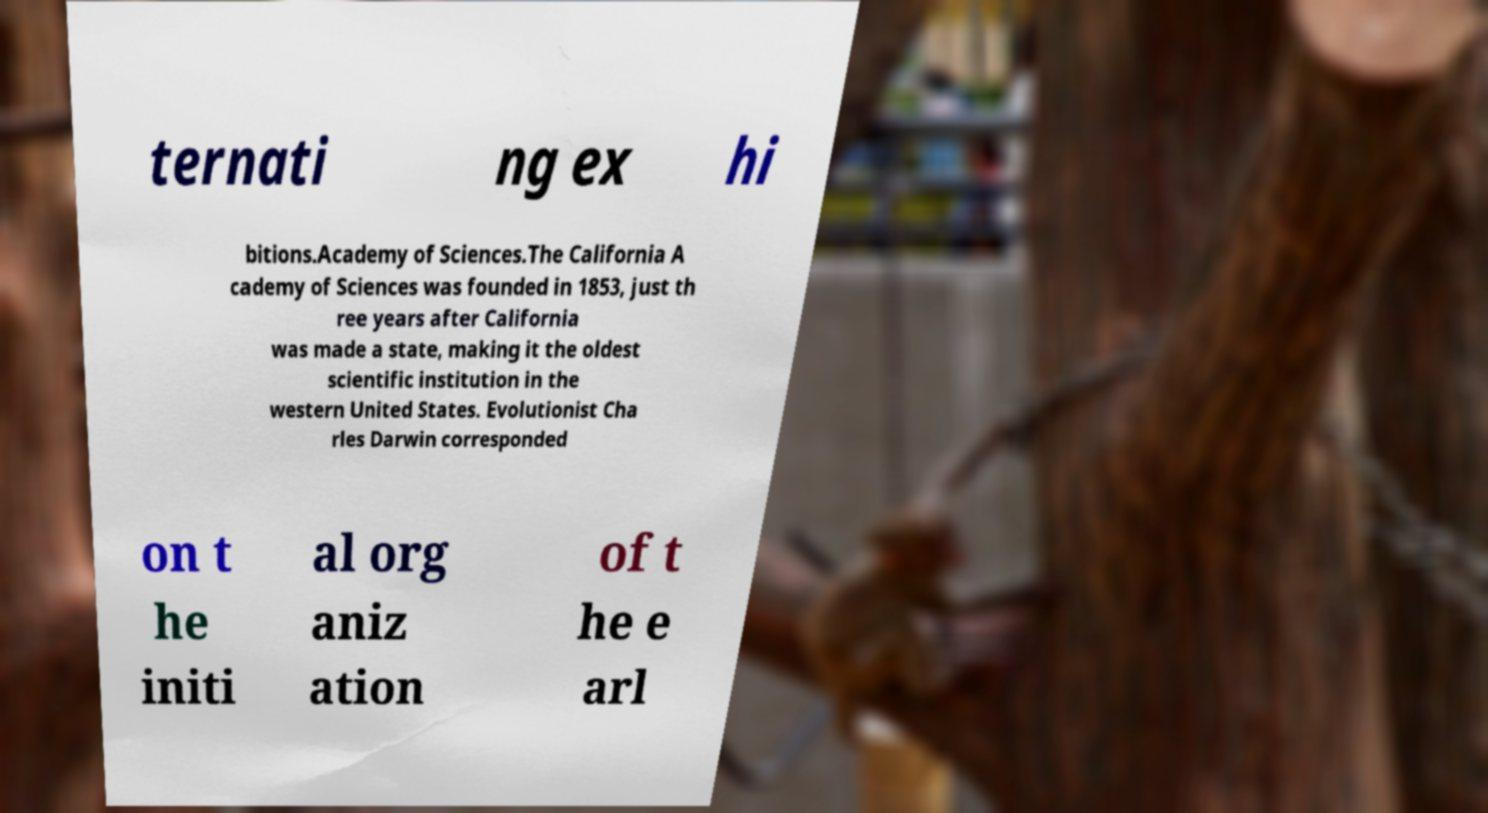Could you extract and type out the text from this image? ternati ng ex hi bitions.Academy of Sciences.The California A cademy of Sciences was founded in 1853, just th ree years after California was made a state, making it the oldest scientific institution in the western United States. Evolutionist Cha rles Darwin corresponded on t he initi al org aniz ation of t he e arl 